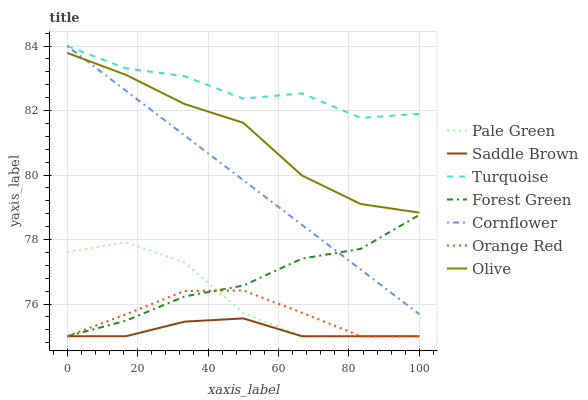Does Saddle Brown have the minimum area under the curve?
Answer yes or no. Yes. Does Turquoise have the maximum area under the curve?
Answer yes or no. Yes. Does Orange Red have the minimum area under the curve?
Answer yes or no. No. Does Orange Red have the maximum area under the curve?
Answer yes or no. No. Is Cornflower the smoothest?
Answer yes or no. Yes. Is Turquoise the roughest?
Answer yes or no. Yes. Is Orange Red the smoothest?
Answer yes or no. No. Is Orange Red the roughest?
Answer yes or no. No. Does Orange Red have the lowest value?
Answer yes or no. Yes. Does Turquoise have the lowest value?
Answer yes or no. No. Does Turquoise have the highest value?
Answer yes or no. Yes. Does Orange Red have the highest value?
Answer yes or no. No. Is Forest Green less than Olive?
Answer yes or no. Yes. Is Cornflower greater than Orange Red?
Answer yes or no. Yes. Does Cornflower intersect Forest Green?
Answer yes or no. Yes. Is Cornflower less than Forest Green?
Answer yes or no. No. Is Cornflower greater than Forest Green?
Answer yes or no. No. Does Forest Green intersect Olive?
Answer yes or no. No. 